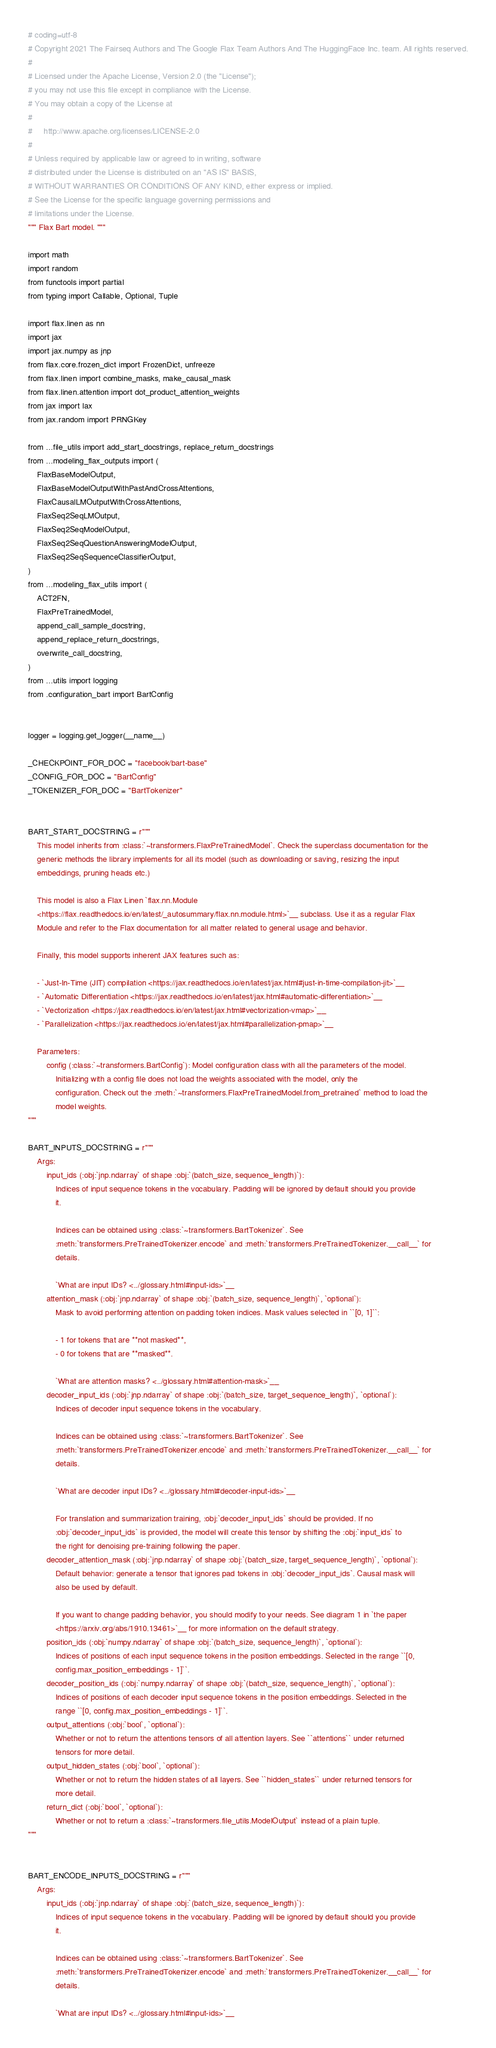<code> <loc_0><loc_0><loc_500><loc_500><_Python_># coding=utf-8
# Copyright 2021 The Fairseq Authors and The Google Flax Team Authors And The HuggingFace Inc. team. All rights reserved.
#
# Licensed under the Apache License, Version 2.0 (the "License");
# you may not use this file except in compliance with the License.
# You may obtain a copy of the License at
#
#     http://www.apache.org/licenses/LICENSE-2.0
#
# Unless required by applicable law or agreed to in writing, software
# distributed under the License is distributed on an "AS IS" BASIS,
# WITHOUT WARRANTIES OR CONDITIONS OF ANY KIND, either express or implied.
# See the License for the specific language governing permissions and
# limitations under the License.
""" Flax Bart model. """

import math
import random
from functools import partial
from typing import Callable, Optional, Tuple

import flax.linen as nn
import jax
import jax.numpy as jnp
from flax.core.frozen_dict import FrozenDict, unfreeze
from flax.linen import combine_masks, make_causal_mask
from flax.linen.attention import dot_product_attention_weights
from jax import lax
from jax.random import PRNGKey

from ...file_utils import add_start_docstrings, replace_return_docstrings
from ...modeling_flax_outputs import (
    FlaxBaseModelOutput,
    FlaxBaseModelOutputWithPastAndCrossAttentions,
    FlaxCausalLMOutputWithCrossAttentions,
    FlaxSeq2SeqLMOutput,
    FlaxSeq2SeqModelOutput,
    FlaxSeq2SeqQuestionAnsweringModelOutput,
    FlaxSeq2SeqSequenceClassifierOutput,
)
from ...modeling_flax_utils import (
    ACT2FN,
    FlaxPreTrainedModel,
    append_call_sample_docstring,
    append_replace_return_docstrings,
    overwrite_call_docstring,
)
from ...utils import logging
from .configuration_bart import BartConfig


logger = logging.get_logger(__name__)

_CHECKPOINT_FOR_DOC = "facebook/bart-base"
_CONFIG_FOR_DOC = "BartConfig"
_TOKENIZER_FOR_DOC = "BartTokenizer"


BART_START_DOCSTRING = r"""
    This model inherits from :class:`~transformers.FlaxPreTrainedModel`. Check the superclass documentation for the
    generic methods the library implements for all its model (such as downloading or saving, resizing the input
    embeddings, pruning heads etc.)

    This model is also a Flax Linen `flax.nn.Module
    <https://flax.readthedocs.io/en/latest/_autosummary/flax.nn.module.html>`__ subclass. Use it as a regular Flax
    Module and refer to the Flax documentation for all matter related to general usage and behavior.

    Finally, this model supports inherent JAX features such as:

    - `Just-In-Time (JIT) compilation <https://jax.readthedocs.io/en/latest/jax.html#just-in-time-compilation-jit>`__
    - `Automatic Differentiation <https://jax.readthedocs.io/en/latest/jax.html#automatic-differentiation>`__
    - `Vectorization <https://jax.readthedocs.io/en/latest/jax.html#vectorization-vmap>`__
    - `Parallelization <https://jax.readthedocs.io/en/latest/jax.html#parallelization-pmap>`__

    Parameters:
        config (:class:`~transformers.BartConfig`): Model configuration class with all the parameters of the model.
            Initializing with a config file does not load the weights associated with the model, only the
            configuration. Check out the :meth:`~transformers.FlaxPreTrainedModel.from_pretrained` method to load the
            model weights.
"""

BART_INPUTS_DOCSTRING = r"""
    Args:
        input_ids (:obj:`jnp.ndarray` of shape :obj:`(batch_size, sequence_length)`):
            Indices of input sequence tokens in the vocabulary. Padding will be ignored by default should you provide
            it.

            Indices can be obtained using :class:`~transformers.BartTokenizer`. See
            :meth:`transformers.PreTrainedTokenizer.encode` and :meth:`transformers.PreTrainedTokenizer.__call__` for
            details.

            `What are input IDs? <../glossary.html#input-ids>`__
        attention_mask (:obj:`jnp.ndarray` of shape :obj:`(batch_size, sequence_length)`, `optional`):
            Mask to avoid performing attention on padding token indices. Mask values selected in ``[0, 1]``:

            - 1 for tokens that are **not masked**,
            - 0 for tokens that are **masked**.

            `What are attention masks? <../glossary.html#attention-mask>`__
        decoder_input_ids (:obj:`jnp.ndarray` of shape :obj:`(batch_size, target_sequence_length)`, `optional`):
            Indices of decoder input sequence tokens in the vocabulary.

            Indices can be obtained using :class:`~transformers.BartTokenizer`. See
            :meth:`transformers.PreTrainedTokenizer.encode` and :meth:`transformers.PreTrainedTokenizer.__call__` for
            details.

            `What are decoder input IDs? <../glossary.html#decoder-input-ids>`__

            For translation and summarization training, :obj:`decoder_input_ids` should be provided. If no
            :obj:`decoder_input_ids` is provided, the model will create this tensor by shifting the :obj:`input_ids` to
            the right for denoising pre-training following the paper.
        decoder_attention_mask (:obj:`jnp.ndarray` of shape :obj:`(batch_size, target_sequence_length)`, `optional`):
            Default behavior: generate a tensor that ignores pad tokens in :obj:`decoder_input_ids`. Causal mask will
            also be used by default.

            If you want to change padding behavior, you should modify to your needs. See diagram 1 in `the paper
            <https://arxiv.org/abs/1910.13461>`__ for more information on the default strategy.
        position_ids (:obj:`numpy.ndarray` of shape :obj:`(batch_size, sequence_length)`, `optional`):
            Indices of positions of each input sequence tokens in the position embeddings. Selected in the range ``[0,
            config.max_position_embeddings - 1]``.
        decoder_position_ids (:obj:`numpy.ndarray` of shape :obj:`(batch_size, sequence_length)`, `optional`):
            Indices of positions of each decoder input sequence tokens in the position embeddings. Selected in the
            range ``[0, config.max_position_embeddings - 1]``.
        output_attentions (:obj:`bool`, `optional`):
            Whether or not to return the attentions tensors of all attention layers. See ``attentions`` under returned
            tensors for more detail.
        output_hidden_states (:obj:`bool`, `optional`):
            Whether or not to return the hidden states of all layers. See ``hidden_states`` under returned tensors for
            more detail.
        return_dict (:obj:`bool`, `optional`):
            Whether or not to return a :class:`~transformers.file_utils.ModelOutput` instead of a plain tuple.
"""


BART_ENCODE_INPUTS_DOCSTRING = r"""
    Args:
        input_ids (:obj:`jnp.ndarray` of shape :obj:`(batch_size, sequence_length)`):
            Indices of input sequence tokens in the vocabulary. Padding will be ignored by default should you provide
            it.

            Indices can be obtained using :class:`~transformers.BartTokenizer`. See
            :meth:`transformers.PreTrainedTokenizer.encode` and :meth:`transformers.PreTrainedTokenizer.__call__` for
            details.

            `What are input IDs? <../glossary.html#input-ids>`__</code> 